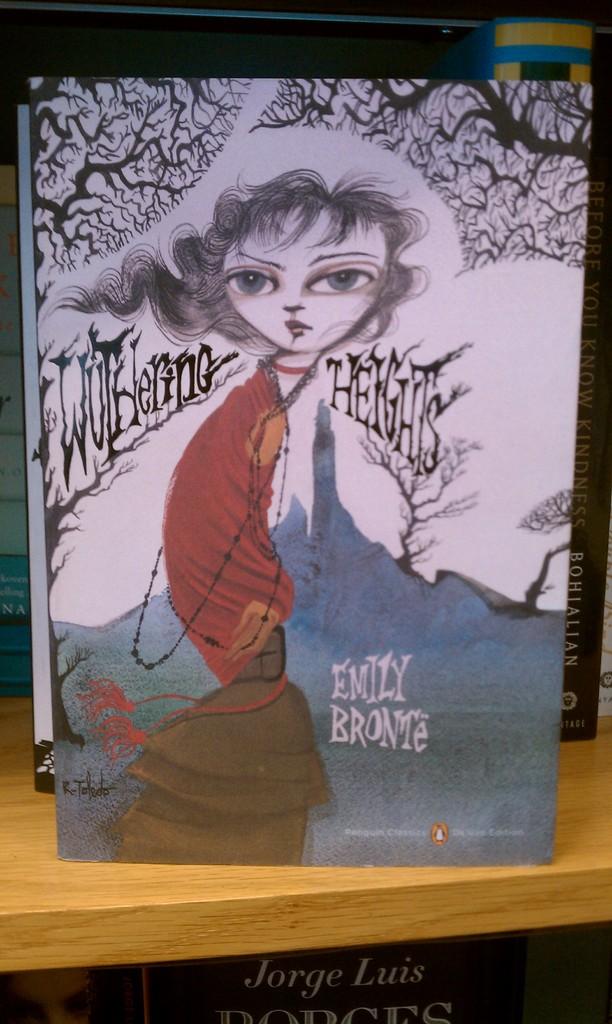What is the title of this book?
Keep it short and to the point. Wuthering heights. Who is the author of the book?
Ensure brevity in your answer.  Emily bronte. 